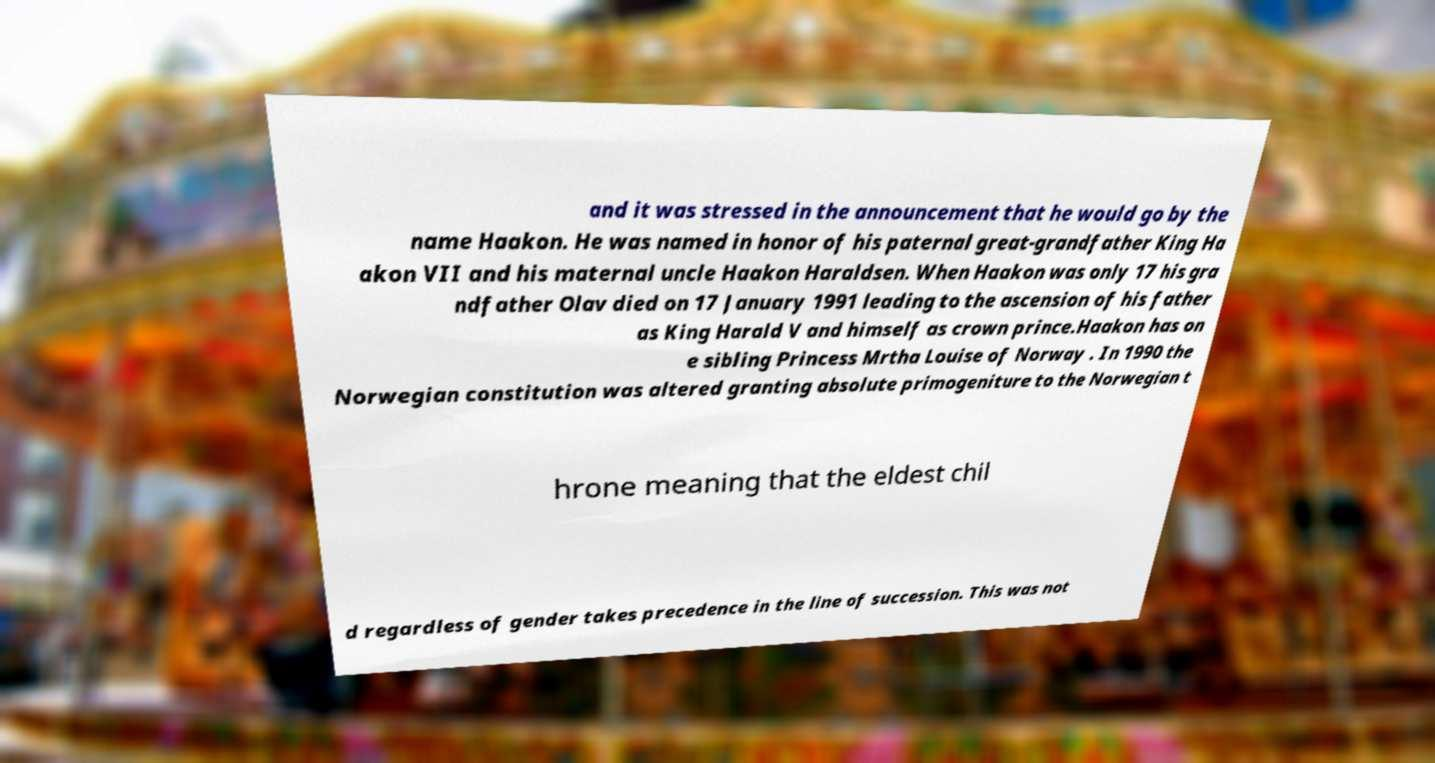Please read and relay the text visible in this image. What does it say? and it was stressed in the announcement that he would go by the name Haakon. He was named in honor of his paternal great-grandfather King Ha akon VII and his maternal uncle Haakon Haraldsen. When Haakon was only 17 his gra ndfather Olav died on 17 January 1991 leading to the ascension of his father as King Harald V and himself as crown prince.Haakon has on e sibling Princess Mrtha Louise of Norway . In 1990 the Norwegian constitution was altered granting absolute primogeniture to the Norwegian t hrone meaning that the eldest chil d regardless of gender takes precedence in the line of succession. This was not 